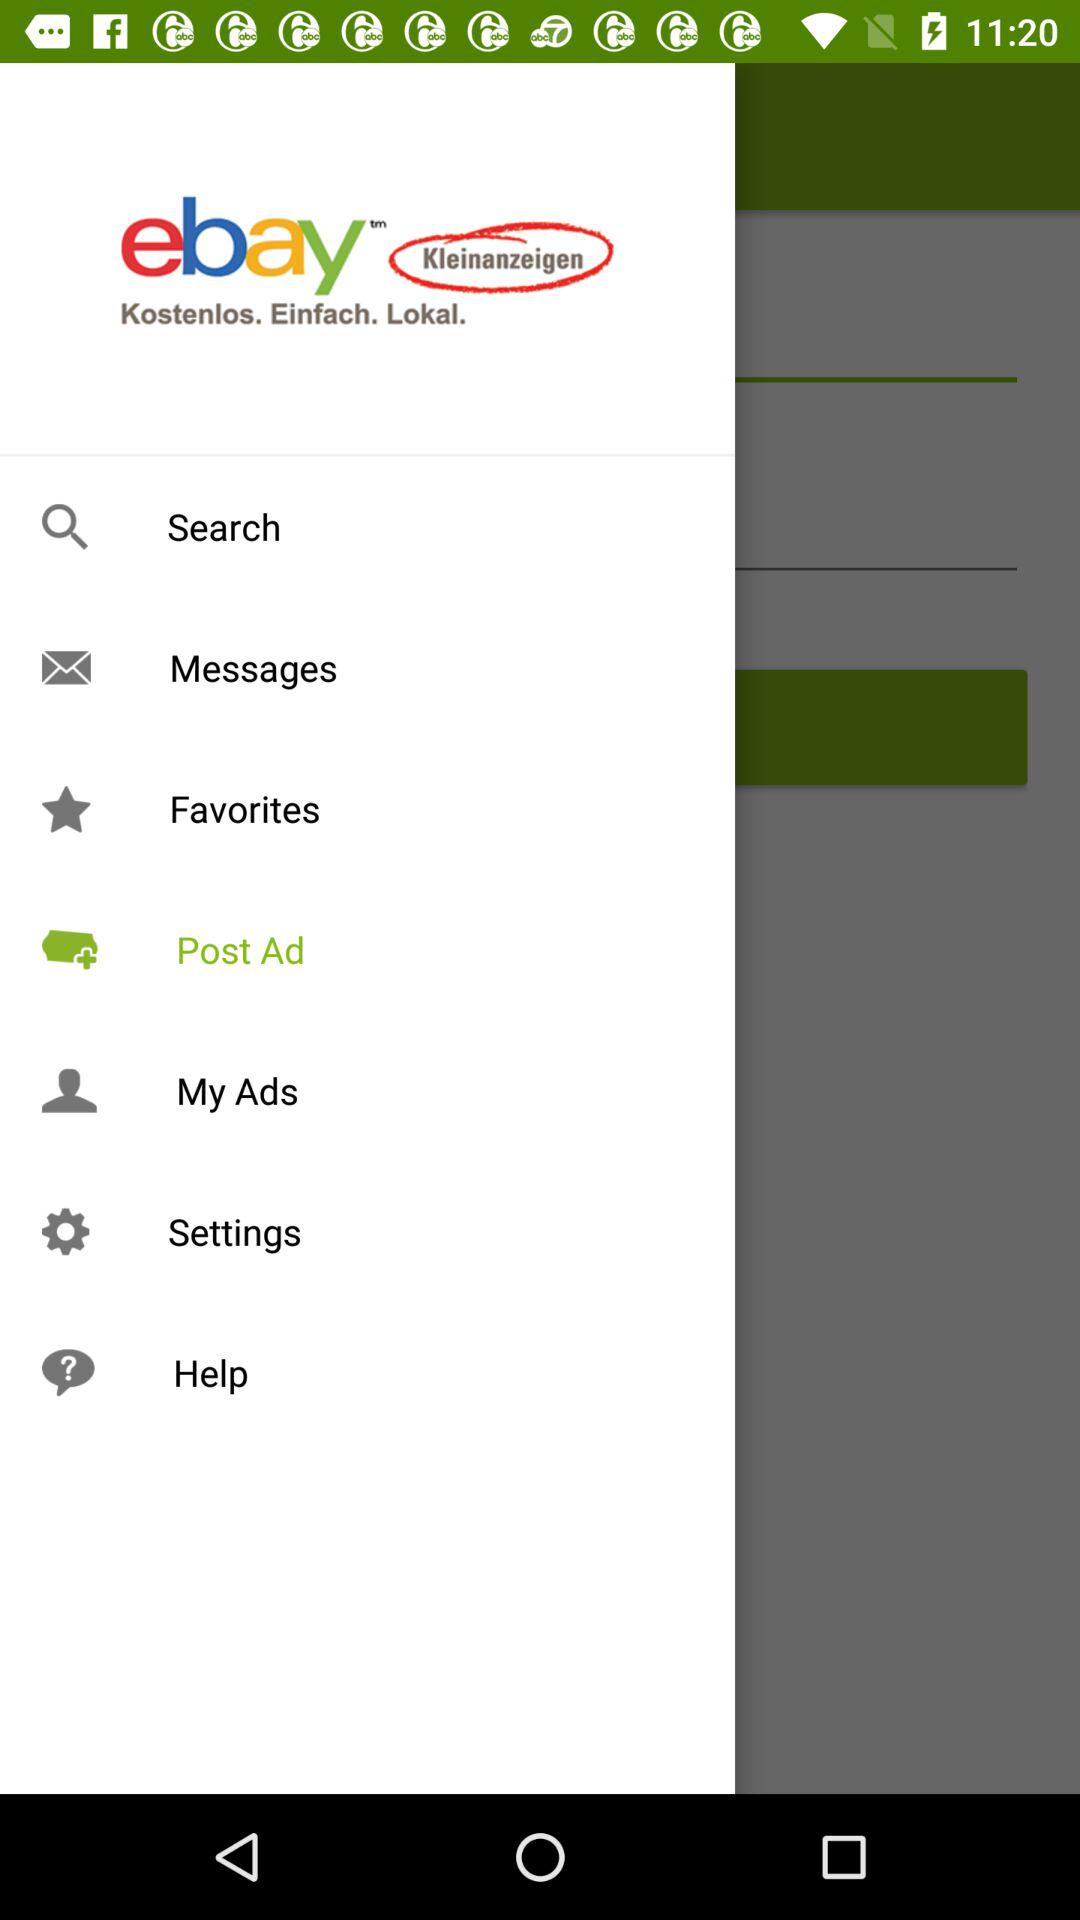Which item is selected? The selected item is "Post Ad". 